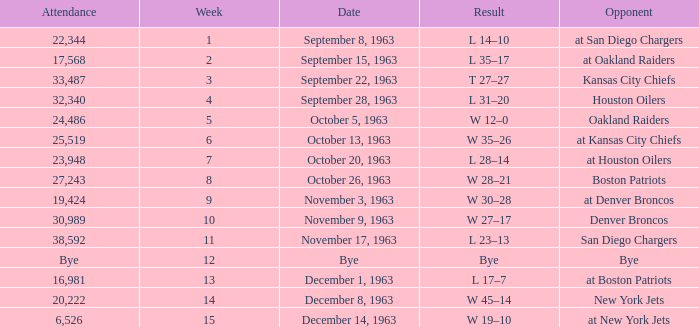Which Opponent has a Result of w 19–10? At new york jets. Write the full table. {'header': ['Attendance', 'Week', 'Date', 'Result', 'Opponent'], 'rows': [['22,344', '1', 'September 8, 1963', 'L 14–10', 'at San Diego Chargers'], ['17,568', '2', 'September 15, 1963', 'L 35–17', 'at Oakland Raiders'], ['33,487', '3', 'September 22, 1963', 'T 27–27', 'Kansas City Chiefs'], ['32,340', '4', 'September 28, 1963', 'L 31–20', 'Houston Oilers'], ['24,486', '5', 'October 5, 1963', 'W 12–0', 'Oakland Raiders'], ['25,519', '6', 'October 13, 1963', 'W 35–26', 'at Kansas City Chiefs'], ['23,948', '7', 'October 20, 1963', 'L 28–14', 'at Houston Oilers'], ['27,243', '8', 'October 26, 1963', 'W 28–21', 'Boston Patriots'], ['19,424', '9', 'November 3, 1963', 'W 30–28', 'at Denver Broncos'], ['30,989', '10', 'November 9, 1963', 'W 27–17', 'Denver Broncos'], ['38,592', '11', 'November 17, 1963', 'L 23–13', 'San Diego Chargers'], ['Bye', '12', 'Bye', 'Bye', 'Bye'], ['16,981', '13', 'December 1, 1963', 'L 17–7', 'at Boston Patriots'], ['20,222', '14', 'December 8, 1963', 'W 45–14', 'New York Jets'], ['6,526', '15', 'December 14, 1963', 'W 19–10', 'at New York Jets']]} 